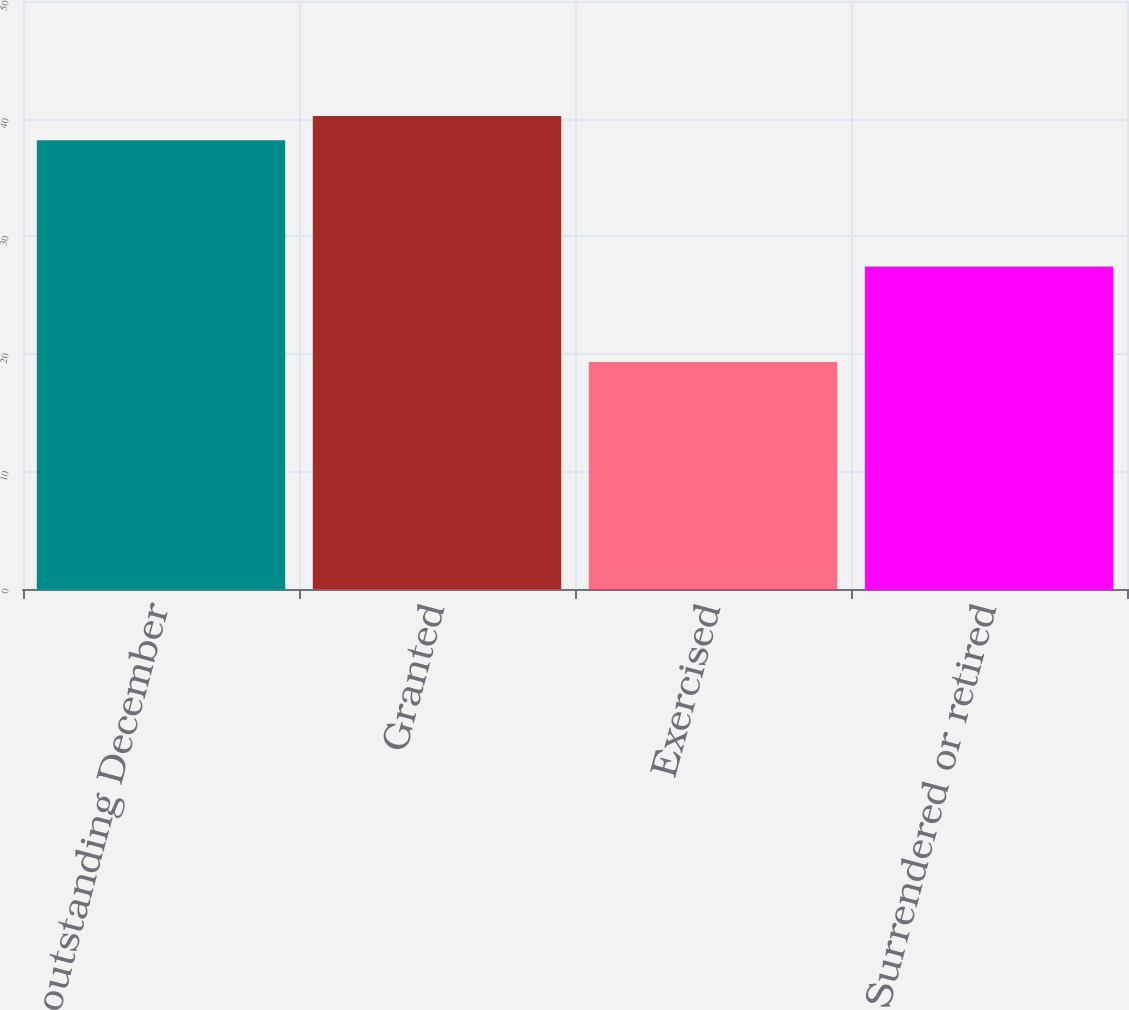Convert chart. <chart><loc_0><loc_0><loc_500><loc_500><bar_chart><fcel>Options outstanding December<fcel>Granted<fcel>Exercised<fcel>Surrendered or retired<nl><fcel>38.15<fcel>40.22<fcel>19.31<fcel>27.43<nl></chart> 